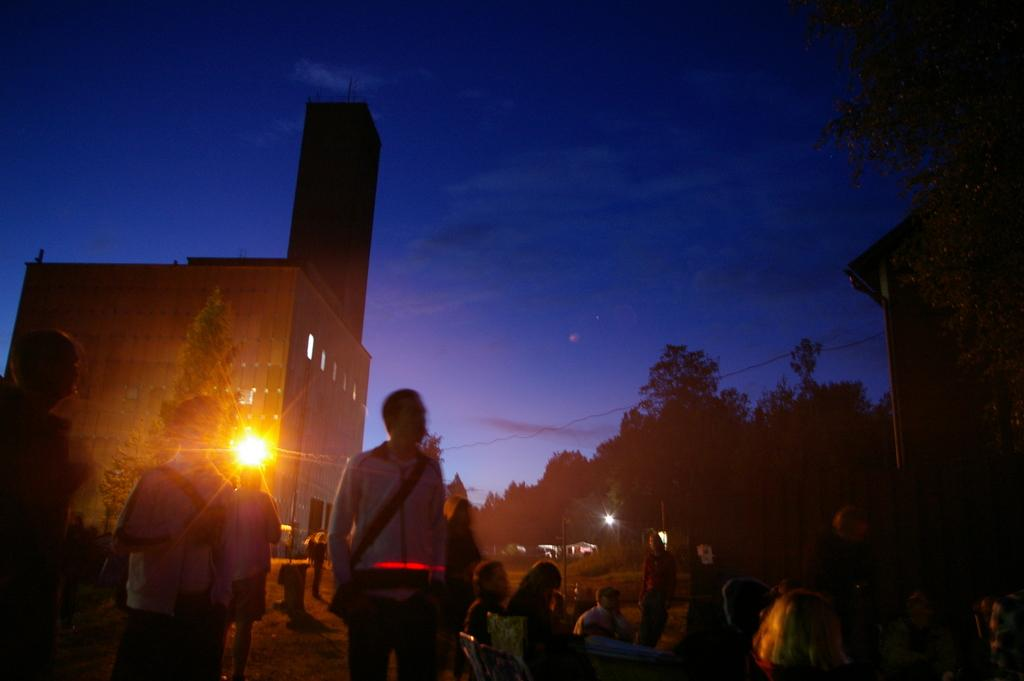What are the people in the image doing? There are persons standing and sitting in the image. What can be seen in the background of the image? There are trees, buildings, lights, and a clear sky visible in the background of the image. What type of quince is being served at the event in the image? There is no event or quince present in the image; it simply shows persons standing and sitting with a background of trees, buildings, lights, and a clear sky. What color is the hair of the secretary in the image? There is no secretary or hair mentioned in the image; it only features persons standing and sitting with a background of trees, buildings, lights, and a clear sky. 